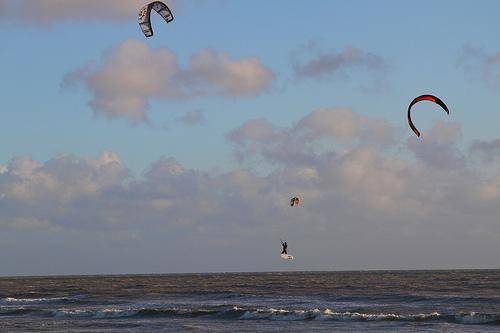Highlight the man's actions in the image and the elements surrounding him. The man is kiteboarding, skillfully maneuvering a board on the ocean while controlling a kite. The environment features a dynamic ocean with visible waves and a sky dotted with clouds. Explain the weather conditions in the image, mentioning any activities taking place. The weather appears moderately windy, suitable for kiteboarding, with a partly cloudy sky. The ocean is active, indicating some wind presence, which is ideal for the sport. Mention the main activity in the image and the conditions of the sky and water. The main activity is kiteboarding, with the man navigating choppy waters. The sky is partly cloudy, and the ocean shows signs of waves, suitable for the sport. Describe the scene in the image, emphasizing the movement in the water and sky. The scene captures a kiteboarder gliding over the ocean's choppy waters, propelled by a kite under a partly cloudy sky, illustrating both motion in the water and the air. Describe the scene in the image with a focus on colors. The image shows a vibrant contrast with the dark blue ocean and the lighter blue sky, punctuated by white and grey clouds. The kite adds a splash of color against the natural backdrop. Narrate the image from the perspective of the man kiteboarding. Riding the waves, I feel the rush of the wind as I maneuver my kite against the backdrop of a vast, open sky and the expansive ocean beneath me. Write a poetic description of the image. Amidst the vast embrace of the ocean, a lone kiteboarder dances with the wind, his kite a colorful whisper against the canvas of the sky and sea. Provide a brief description of what's happening in the image. A man is kiteboarding in the ocean, skillfully controlling a kite as he navigates through the waves under a partly cloudy sky. Summarize the scene in the image in one sentence. A kiteboarder harnesses the wind to surf the ocean's waves under a sky scattered with clouds. Mention the most striking feature in the image and how it relates to the environment. The dynamic interaction between the kiteboarder and the elements—wind, water, and sky—highlights the thrilling nature of the sport and its reliance on natural conditions. 